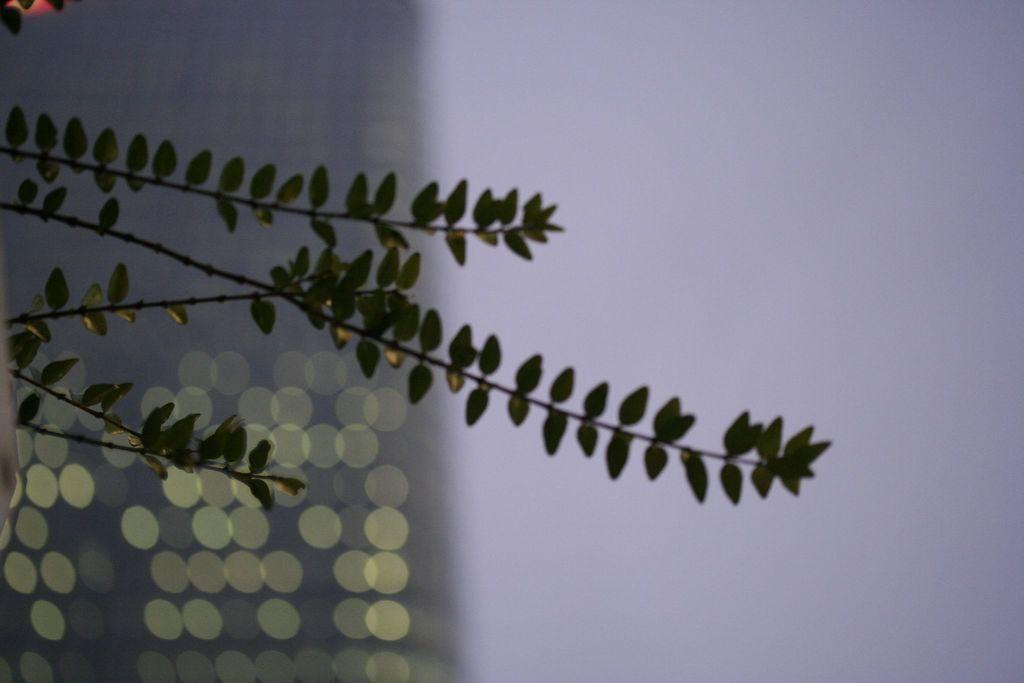What type of natural elements are present in the image? The image contains leaves of a tree. What type of toothpaste is visible on the leaves in the image? There is no toothpaste present on the leaves in the image. 